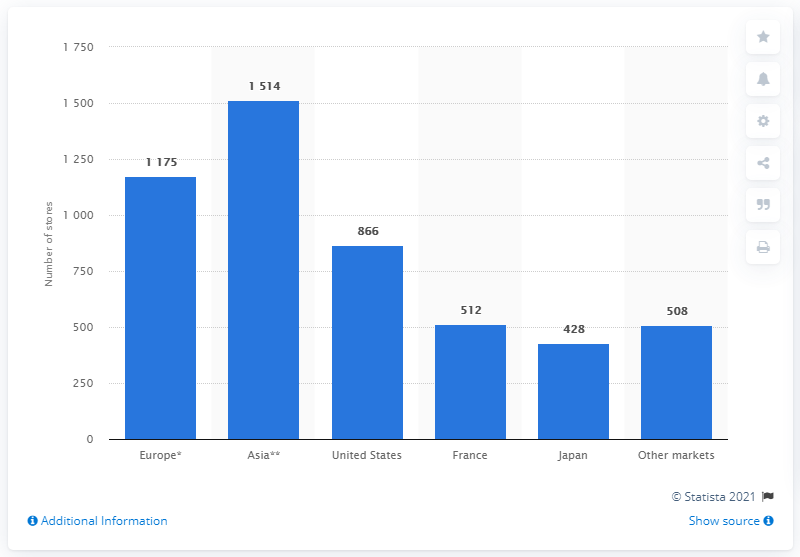Draw attention to some important aspects in this diagram. In 2020, the LVMH Group operated 866 stores in the United States. 